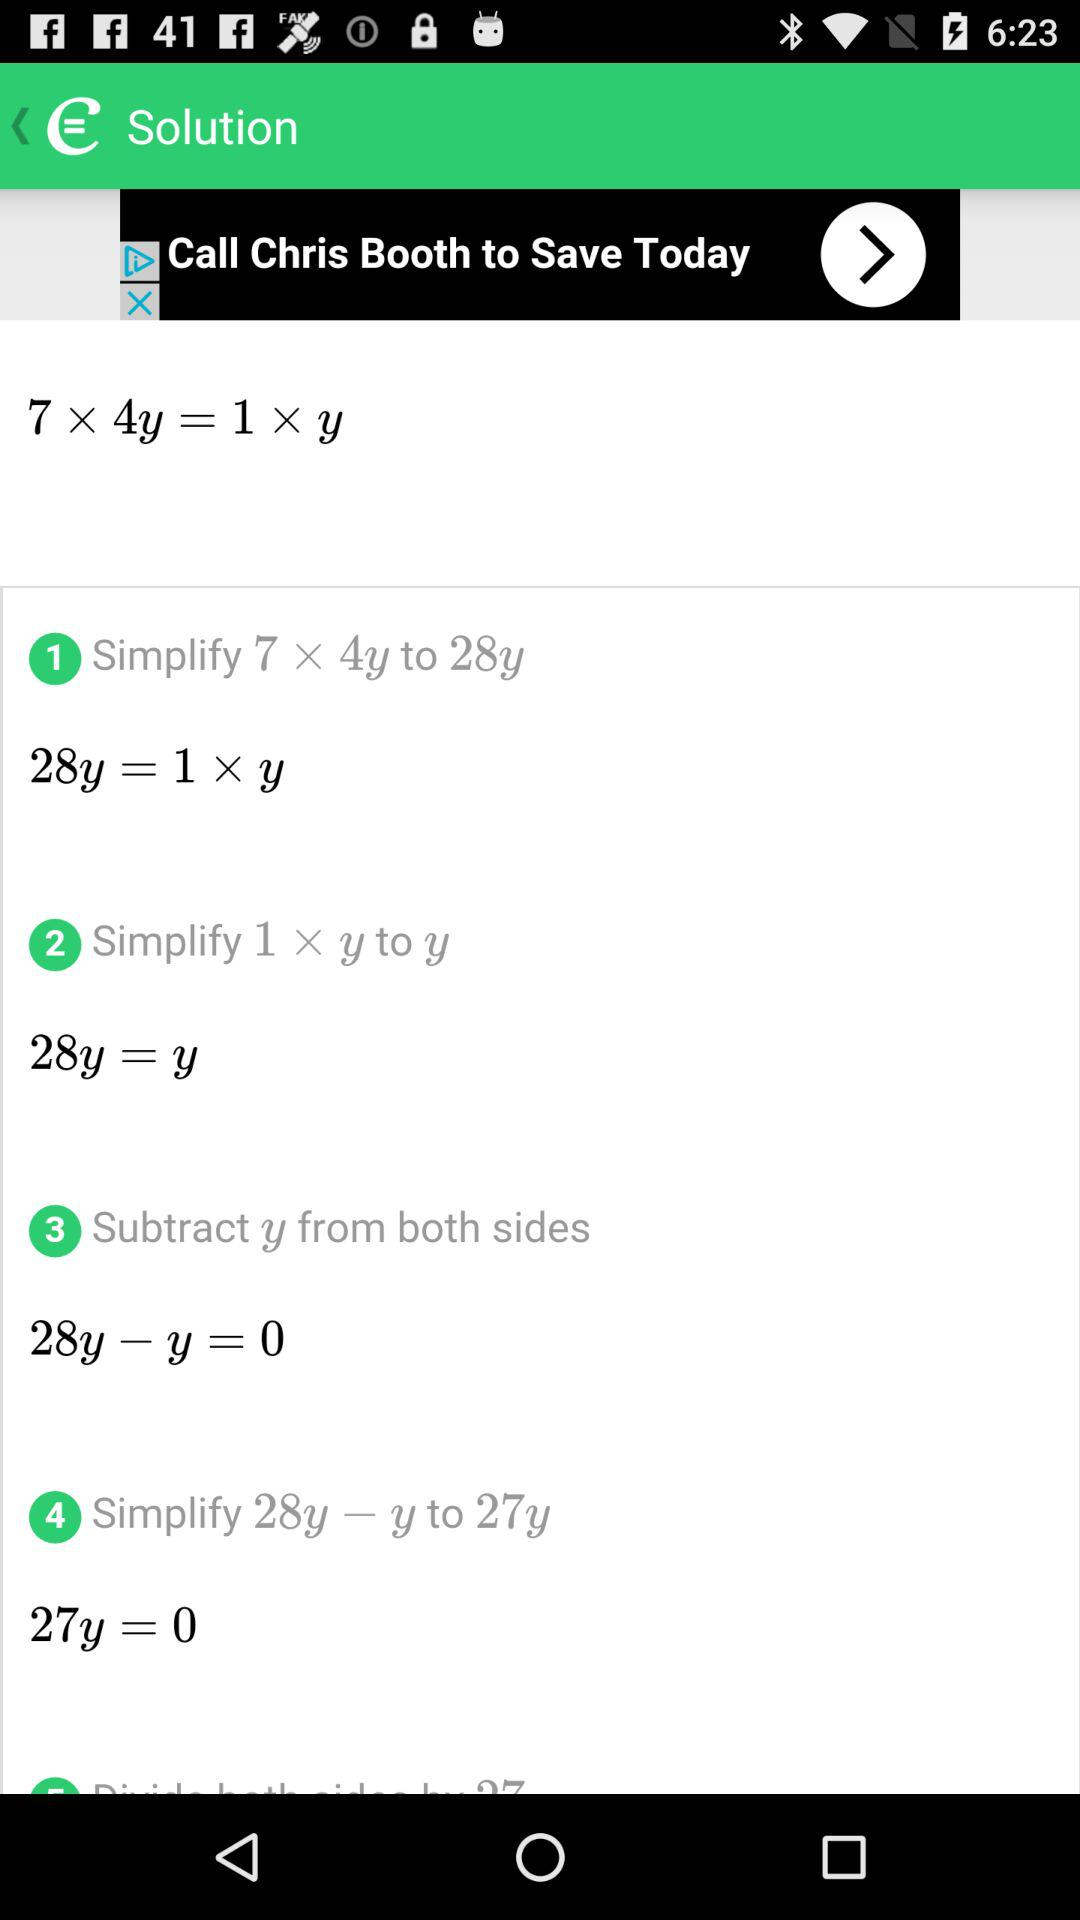What is the value of y?
Answer the question using a single word or phrase. 0 